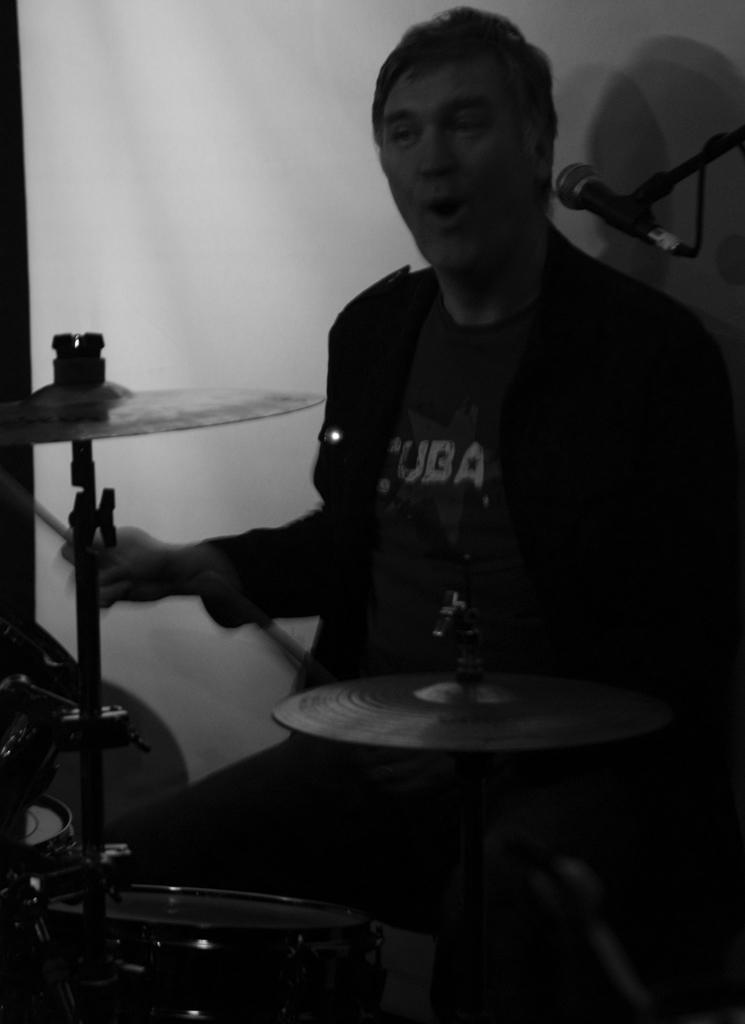What is the color scheme of the image? The image is black and white. What is the main subject of the image? There is a person in the middle of the image. What is the person doing in the image? The person is playing drums. What type of belief is depicted in the image? There is no belief depicted in the image; it features a person playing drums. Can you tell me how many spades are visible in the image? There are no spades present in the image. 